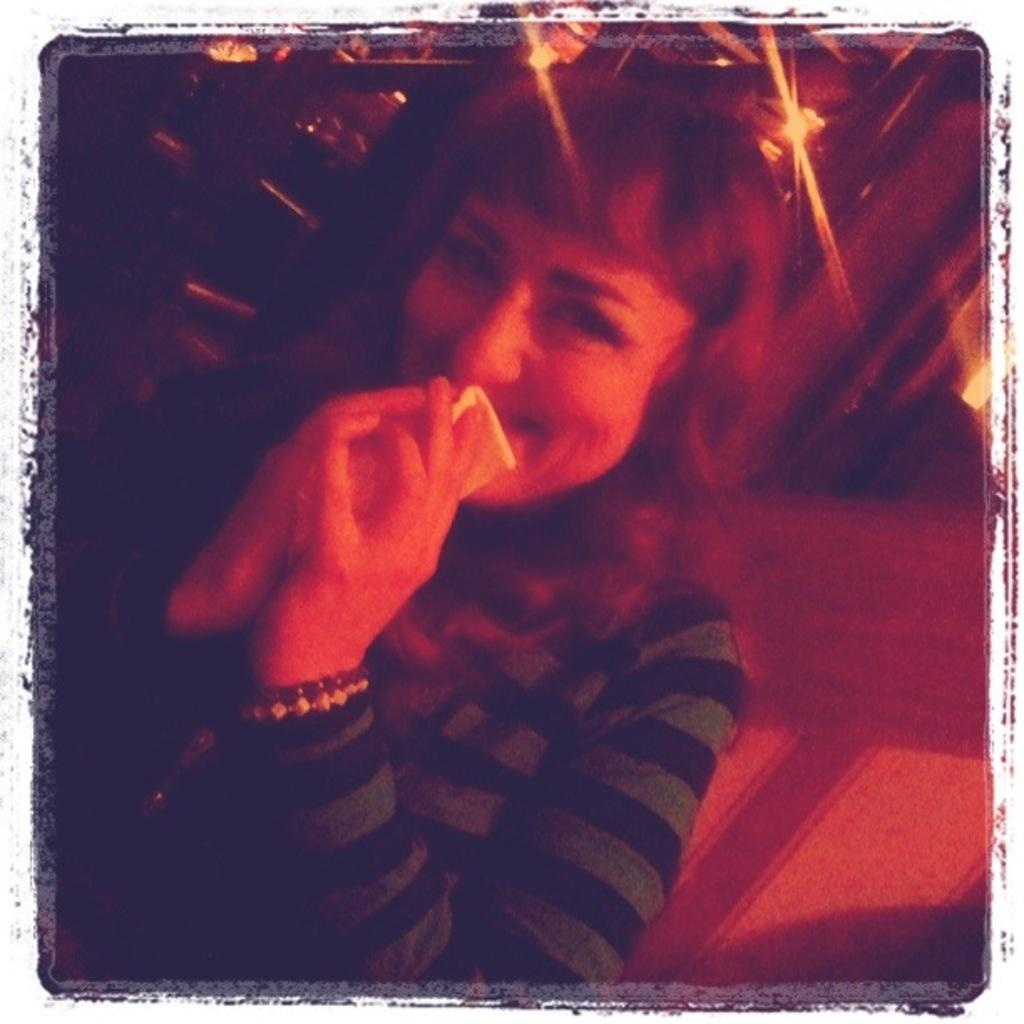Who is present in the image? There is a woman in the image. What can be seen at the top of the image? There are lights visible at the top of the image. What type of flame can be seen near the woman in the image? There is no flame present in the image. Is there a wren perched on the woman's shoulder in the image? There is no wren present in the image. 